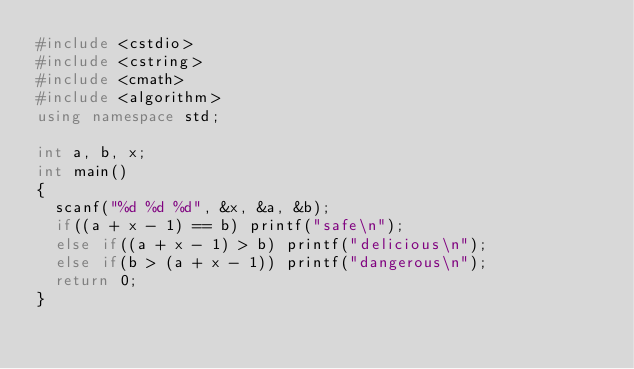Convert code to text. <code><loc_0><loc_0><loc_500><loc_500><_C++_>#include <cstdio>
#include <cstring>
#include <cmath>
#include <algorithm>
using namespace std;

int a, b, x;
int main()
{
	scanf("%d %d %d", &x, &a, &b);
	if((a + x - 1) == b) printf("safe\n");
	else if((a + x - 1) > b) printf("delicious\n");
	else if(b > (a + x - 1)) printf("dangerous\n");
	return 0;
}</code> 